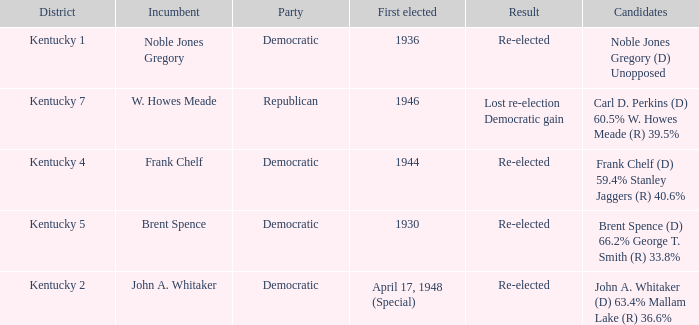What was the result in the voting district Kentucky 2? Re-elected. 